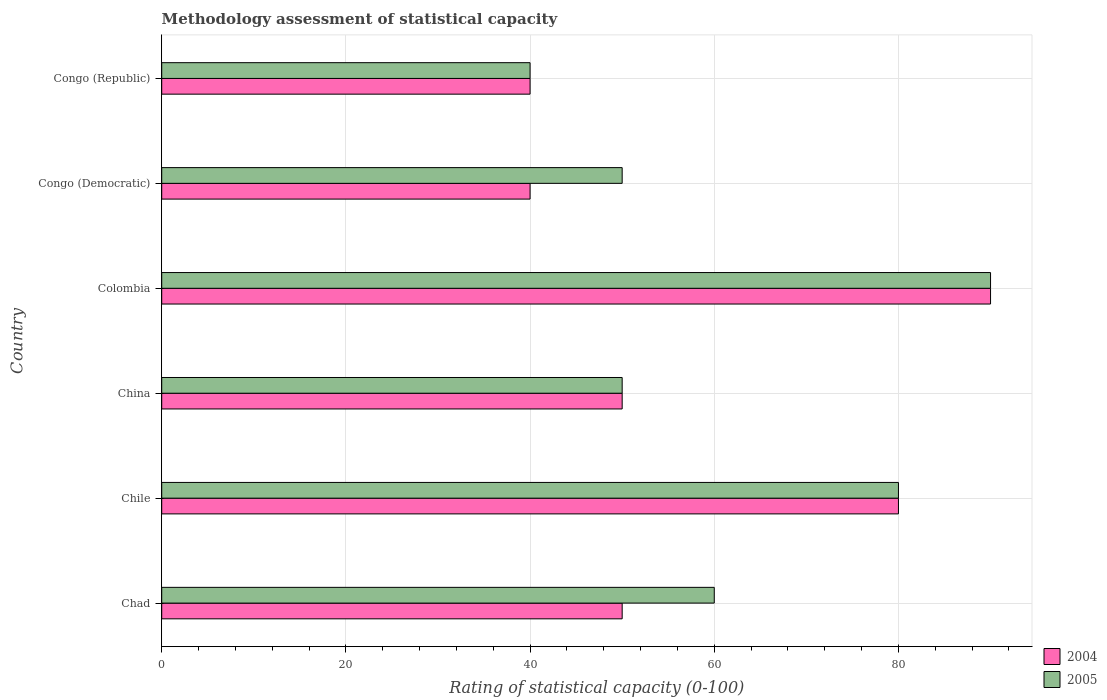Are the number of bars on each tick of the Y-axis equal?
Provide a short and direct response. Yes. How many bars are there on the 4th tick from the bottom?
Offer a very short reply. 2. What is the label of the 6th group of bars from the top?
Your answer should be very brief. Chad. Across all countries, what is the maximum rating of statistical capacity in 2004?
Your answer should be compact. 90. Across all countries, what is the minimum rating of statistical capacity in 2005?
Your response must be concise. 40. In which country was the rating of statistical capacity in 2004 minimum?
Make the answer very short. Congo (Democratic). What is the total rating of statistical capacity in 2004 in the graph?
Provide a short and direct response. 350. What is the difference between the rating of statistical capacity in 2005 in Chile and the rating of statistical capacity in 2004 in Colombia?
Keep it short and to the point. -10. What is the average rating of statistical capacity in 2004 per country?
Make the answer very short. 58.33. What is the difference between the rating of statistical capacity in 2004 and rating of statistical capacity in 2005 in Chad?
Keep it short and to the point. -10. Is the difference between the rating of statistical capacity in 2004 in Chile and China greater than the difference between the rating of statistical capacity in 2005 in Chile and China?
Give a very brief answer. No. What is the difference between the highest and the lowest rating of statistical capacity in 2005?
Offer a terse response. 50. What does the 1st bar from the bottom in Chile represents?
Your response must be concise. 2004. How many bars are there?
Make the answer very short. 12. How many countries are there in the graph?
Give a very brief answer. 6. How are the legend labels stacked?
Your answer should be compact. Vertical. What is the title of the graph?
Offer a terse response. Methodology assessment of statistical capacity. What is the label or title of the X-axis?
Your answer should be compact. Rating of statistical capacity (0-100). What is the Rating of statistical capacity (0-100) of 2004 in China?
Give a very brief answer. 50. What is the Rating of statistical capacity (0-100) in 2005 in Colombia?
Give a very brief answer. 90. What is the Rating of statistical capacity (0-100) in 2004 in Congo (Democratic)?
Give a very brief answer. 40. What is the Rating of statistical capacity (0-100) in 2004 in Congo (Republic)?
Offer a very short reply. 40. Across all countries, what is the minimum Rating of statistical capacity (0-100) in 2005?
Provide a short and direct response. 40. What is the total Rating of statistical capacity (0-100) in 2004 in the graph?
Keep it short and to the point. 350. What is the total Rating of statistical capacity (0-100) of 2005 in the graph?
Make the answer very short. 370. What is the difference between the Rating of statistical capacity (0-100) of 2004 in Chad and that in China?
Give a very brief answer. 0. What is the difference between the Rating of statistical capacity (0-100) of 2004 in Chad and that in Colombia?
Provide a succinct answer. -40. What is the difference between the Rating of statistical capacity (0-100) in 2004 in Chile and that in Colombia?
Your response must be concise. -10. What is the difference between the Rating of statistical capacity (0-100) of 2004 in Chile and that in Congo (Democratic)?
Provide a succinct answer. 40. What is the difference between the Rating of statistical capacity (0-100) of 2005 in Chile and that in Congo (Democratic)?
Keep it short and to the point. 30. What is the difference between the Rating of statistical capacity (0-100) in 2004 in Chile and that in Congo (Republic)?
Offer a very short reply. 40. What is the difference between the Rating of statistical capacity (0-100) in 2004 in China and that in Colombia?
Give a very brief answer. -40. What is the difference between the Rating of statistical capacity (0-100) of 2005 in China and that in Colombia?
Your answer should be very brief. -40. What is the difference between the Rating of statistical capacity (0-100) in 2005 in China and that in Congo (Democratic)?
Ensure brevity in your answer.  0. What is the difference between the Rating of statistical capacity (0-100) in 2004 in China and that in Congo (Republic)?
Provide a short and direct response. 10. What is the difference between the Rating of statistical capacity (0-100) of 2005 in China and that in Congo (Republic)?
Your answer should be compact. 10. What is the difference between the Rating of statistical capacity (0-100) in 2005 in Colombia and that in Congo (Democratic)?
Keep it short and to the point. 40. What is the difference between the Rating of statistical capacity (0-100) of 2005 in Colombia and that in Congo (Republic)?
Provide a short and direct response. 50. What is the difference between the Rating of statistical capacity (0-100) in 2004 in Congo (Democratic) and that in Congo (Republic)?
Make the answer very short. 0. What is the difference between the Rating of statistical capacity (0-100) of 2005 in Congo (Democratic) and that in Congo (Republic)?
Provide a succinct answer. 10. What is the difference between the Rating of statistical capacity (0-100) of 2004 in Chad and the Rating of statistical capacity (0-100) of 2005 in Chile?
Your response must be concise. -30. What is the difference between the Rating of statistical capacity (0-100) in 2004 in Chad and the Rating of statistical capacity (0-100) in 2005 in Congo (Republic)?
Your answer should be compact. 10. What is the difference between the Rating of statistical capacity (0-100) in 2004 in Chile and the Rating of statistical capacity (0-100) in 2005 in Congo (Democratic)?
Your answer should be very brief. 30. What is the difference between the Rating of statistical capacity (0-100) in 2004 in China and the Rating of statistical capacity (0-100) in 2005 in Congo (Democratic)?
Offer a terse response. 0. What is the difference between the Rating of statistical capacity (0-100) of 2004 in China and the Rating of statistical capacity (0-100) of 2005 in Congo (Republic)?
Give a very brief answer. 10. What is the difference between the Rating of statistical capacity (0-100) in 2004 in Colombia and the Rating of statistical capacity (0-100) in 2005 in Congo (Republic)?
Make the answer very short. 50. What is the average Rating of statistical capacity (0-100) in 2004 per country?
Give a very brief answer. 58.33. What is the average Rating of statistical capacity (0-100) of 2005 per country?
Offer a very short reply. 61.67. What is the difference between the Rating of statistical capacity (0-100) of 2004 and Rating of statistical capacity (0-100) of 2005 in Chad?
Keep it short and to the point. -10. What is the difference between the Rating of statistical capacity (0-100) in 2004 and Rating of statistical capacity (0-100) in 2005 in China?
Offer a very short reply. 0. What is the difference between the Rating of statistical capacity (0-100) in 2004 and Rating of statistical capacity (0-100) in 2005 in Colombia?
Provide a succinct answer. 0. What is the ratio of the Rating of statistical capacity (0-100) in 2004 in Chad to that in China?
Offer a terse response. 1. What is the ratio of the Rating of statistical capacity (0-100) in 2005 in Chad to that in China?
Provide a succinct answer. 1.2. What is the ratio of the Rating of statistical capacity (0-100) of 2004 in Chad to that in Colombia?
Ensure brevity in your answer.  0.56. What is the ratio of the Rating of statistical capacity (0-100) of 2004 in Chad to that in Congo (Democratic)?
Your answer should be compact. 1.25. What is the ratio of the Rating of statistical capacity (0-100) of 2005 in Chad to that in Congo (Democratic)?
Make the answer very short. 1.2. What is the ratio of the Rating of statistical capacity (0-100) in 2004 in Chad to that in Congo (Republic)?
Offer a terse response. 1.25. What is the ratio of the Rating of statistical capacity (0-100) in 2005 in Chile to that in China?
Offer a terse response. 1.6. What is the ratio of the Rating of statistical capacity (0-100) of 2005 in Chile to that in Colombia?
Give a very brief answer. 0.89. What is the ratio of the Rating of statistical capacity (0-100) of 2004 in Chile to that in Congo (Democratic)?
Ensure brevity in your answer.  2. What is the ratio of the Rating of statistical capacity (0-100) of 2004 in Chile to that in Congo (Republic)?
Ensure brevity in your answer.  2. What is the ratio of the Rating of statistical capacity (0-100) in 2005 in Chile to that in Congo (Republic)?
Your answer should be compact. 2. What is the ratio of the Rating of statistical capacity (0-100) in 2004 in China to that in Colombia?
Offer a very short reply. 0.56. What is the ratio of the Rating of statistical capacity (0-100) of 2005 in China to that in Colombia?
Offer a terse response. 0.56. What is the ratio of the Rating of statistical capacity (0-100) in 2004 in China to that in Congo (Democratic)?
Your answer should be compact. 1.25. What is the ratio of the Rating of statistical capacity (0-100) in 2005 in China to that in Congo (Democratic)?
Ensure brevity in your answer.  1. What is the ratio of the Rating of statistical capacity (0-100) in 2005 in China to that in Congo (Republic)?
Offer a terse response. 1.25. What is the ratio of the Rating of statistical capacity (0-100) of 2004 in Colombia to that in Congo (Democratic)?
Make the answer very short. 2.25. What is the ratio of the Rating of statistical capacity (0-100) in 2004 in Colombia to that in Congo (Republic)?
Make the answer very short. 2.25. What is the ratio of the Rating of statistical capacity (0-100) in 2005 in Colombia to that in Congo (Republic)?
Your answer should be very brief. 2.25. What is the difference between the highest and the second highest Rating of statistical capacity (0-100) in 2004?
Keep it short and to the point. 10. What is the difference between the highest and the lowest Rating of statistical capacity (0-100) in 2004?
Make the answer very short. 50. What is the difference between the highest and the lowest Rating of statistical capacity (0-100) of 2005?
Keep it short and to the point. 50. 